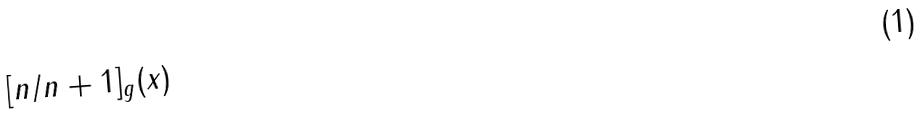Convert formula to latex. <formula><loc_0><loc_0><loc_500><loc_500>[ n / n + 1 ] _ { g } ( x )</formula> 